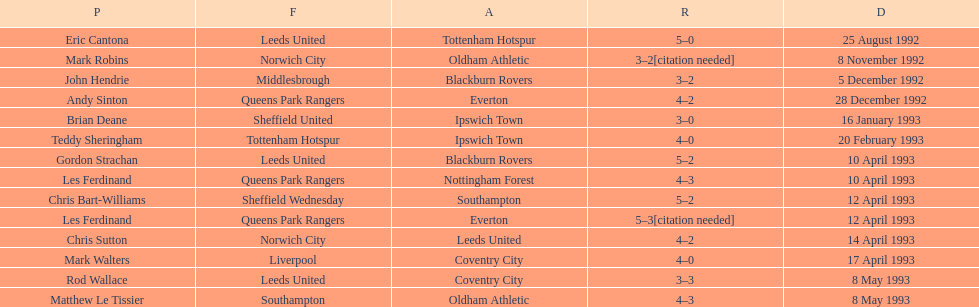Which player had the same result as mark robins? John Hendrie. 